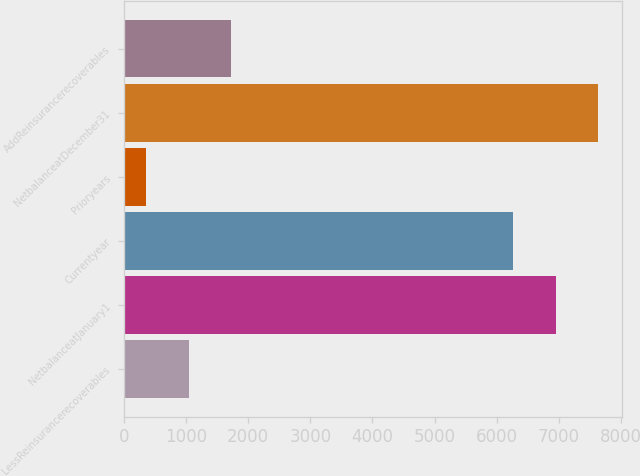<chart> <loc_0><loc_0><loc_500><loc_500><bar_chart><fcel>LessReinsurancerecoverables<fcel>NetbalanceatJanuary1<fcel>Currentyear<fcel>Prioryears<fcel>NetbalanceatDecember31<fcel>AddReinsurancerecoverables<nl><fcel>1039.5<fcel>6949.5<fcel>6263<fcel>353<fcel>7636<fcel>1726<nl></chart> 